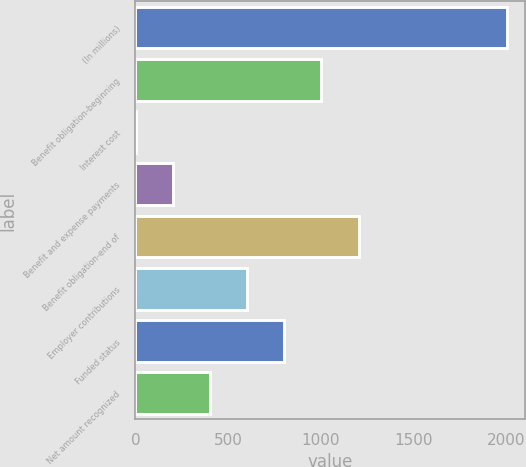Convert chart to OTSL. <chart><loc_0><loc_0><loc_500><loc_500><bar_chart><fcel>(In millions)<fcel>Benefit obligation-beginning<fcel>Interest cost<fcel>Benefit and expense payments<fcel>Benefit obligation-end of<fcel>Employer contributions<fcel>Funded status<fcel>Net amount recognized<nl><fcel>2006<fcel>1004.7<fcel>3.4<fcel>203.66<fcel>1204.96<fcel>604.18<fcel>804.44<fcel>403.92<nl></chart> 